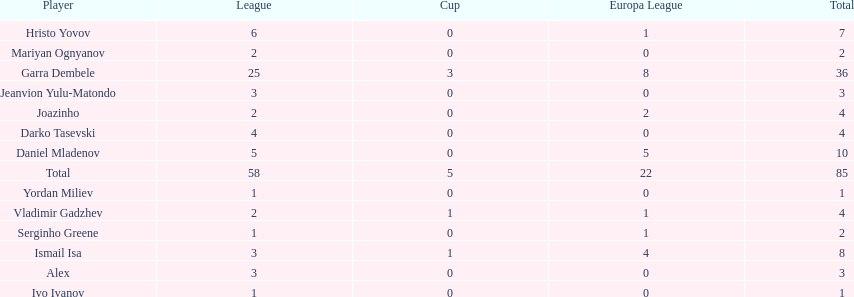Which players only scored one goal? Serginho Greene, Yordan Miliev, Ivo Ivanov. 